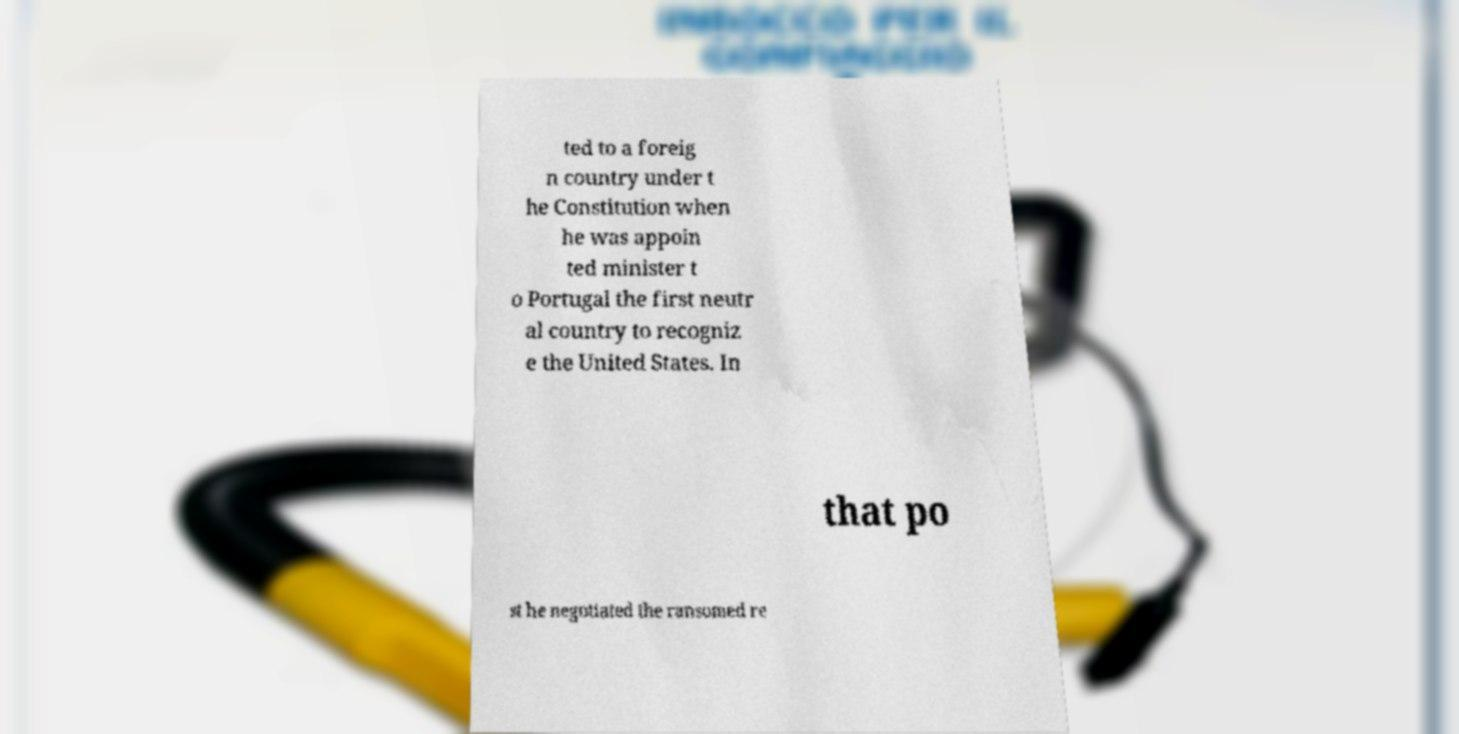For documentation purposes, I need the text within this image transcribed. Could you provide that? ted to a foreig n country under t he Constitution when he was appoin ted minister t o Portugal the first neutr al country to recogniz e the United States. In that po st he negotiated the ransomed re 